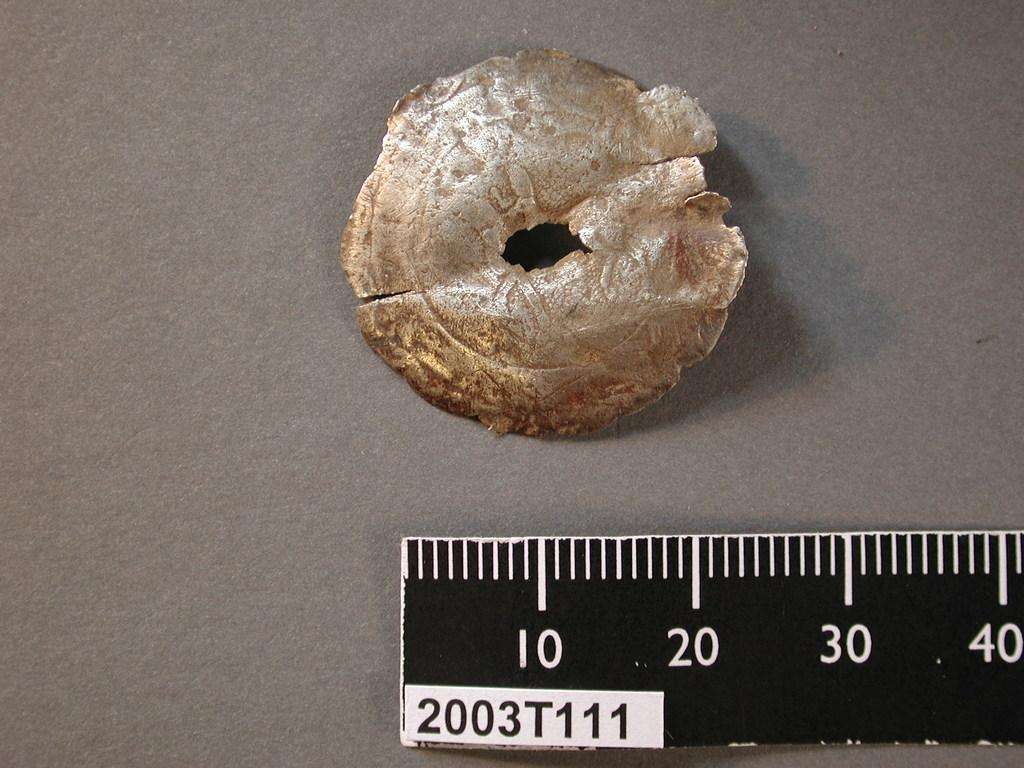<image>
Present a compact description of the photo's key features. A food item being measured by a ruler with the lettering 2003T111. 